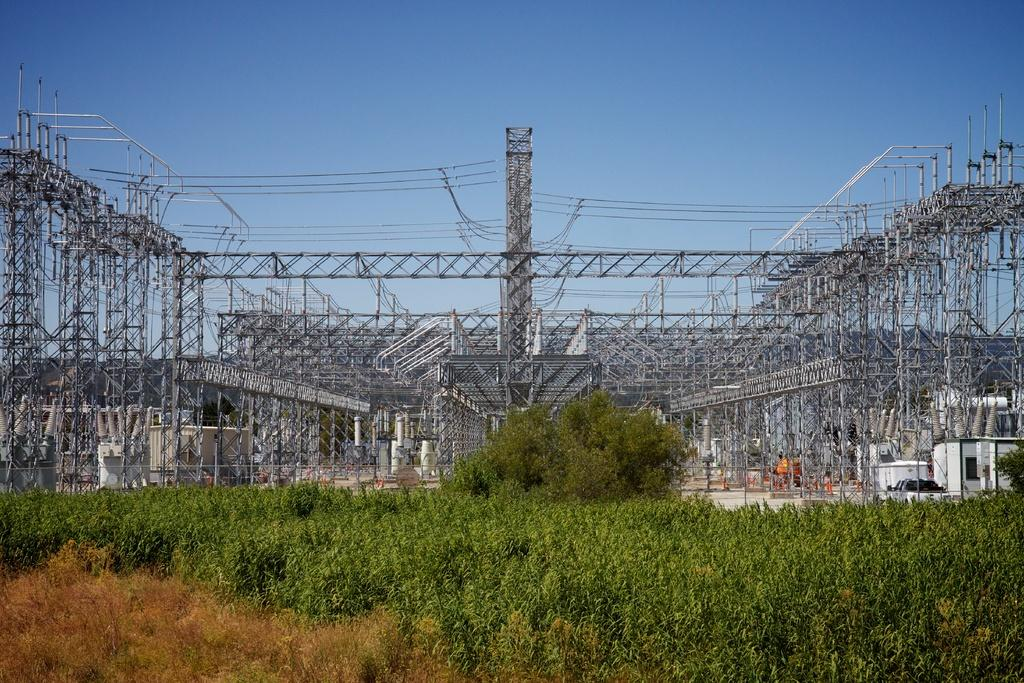What type of natural elements can be seen in the image? There are plants and a tree in the image. What man-made structures are present in the image? There are wires and towers in the image. Can you describe any other objects in the image? Yes, there are other objects in the image, but their specific nature is not mentioned in the facts. What can be seen in the background of the image? The sky is visible in the background of the image. What type of chalk is being used to draw on the tree in the image? There is no chalk or drawing activity present in the image; it features plants, a tree, wires, towers, and other objects. 